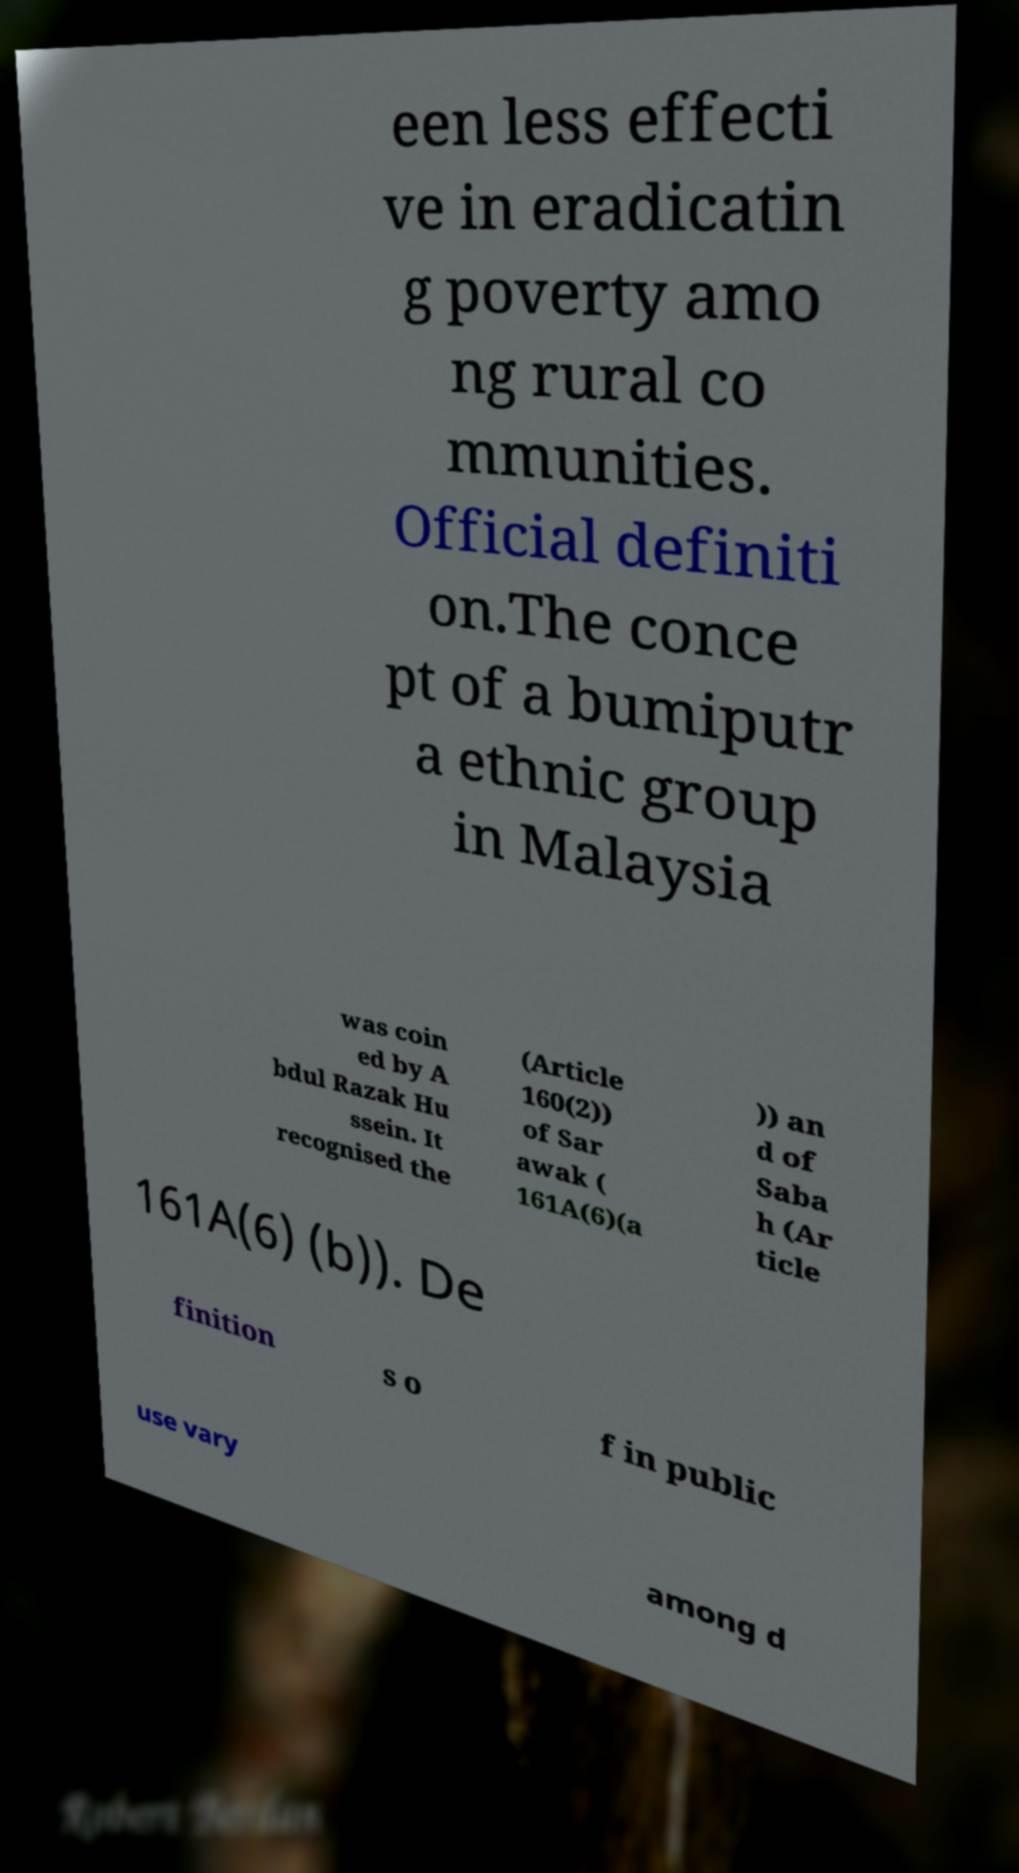Please identify and transcribe the text found in this image. een less effecti ve in eradicatin g poverty amo ng rural co mmunities. Official definiti on.The conce pt of a bumiputr a ethnic group in Malaysia was coin ed by A bdul Razak Hu ssein. It recognised the (Article 160(2)) of Sar awak ( 161A(6)(a )) an d of Saba h (Ar ticle 161A(6) (b)). De finition s o f in public use vary among d 